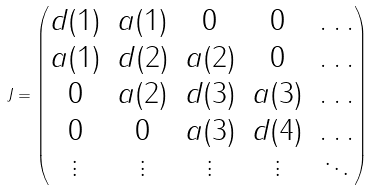<formula> <loc_0><loc_0><loc_500><loc_500>J = \begin{pmatrix} d ( 1 ) & a ( 1 ) & 0 & 0 & \dots \\ a ( 1 ) & d ( 2 ) & a ( 2 ) & 0 & \dots \\ 0 & a ( 2 ) & d ( 3 ) & a ( 3 ) & \dots \\ 0 & 0 & a ( 3 ) & d ( 4 ) & \dots \\ \vdots & \vdots & \vdots & \vdots & \ddots \end{pmatrix}</formula> 